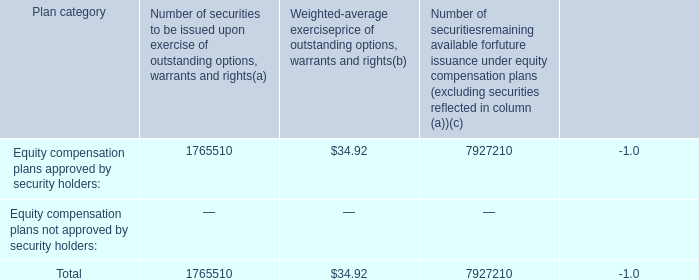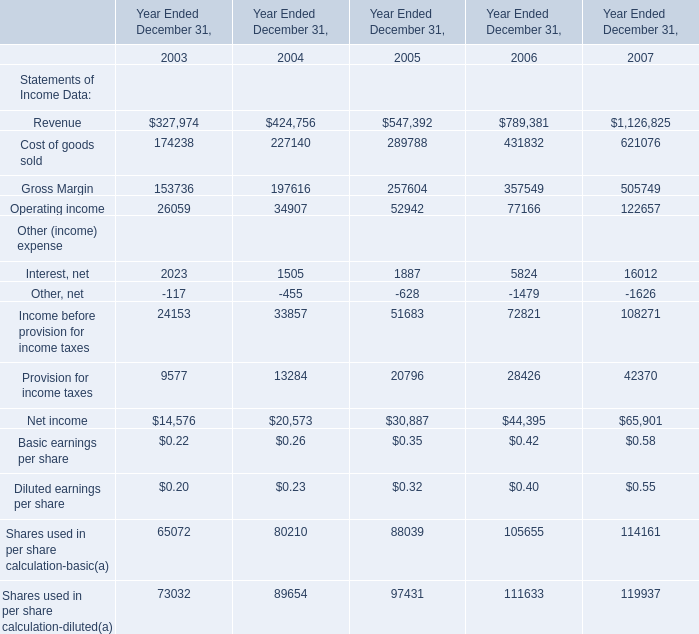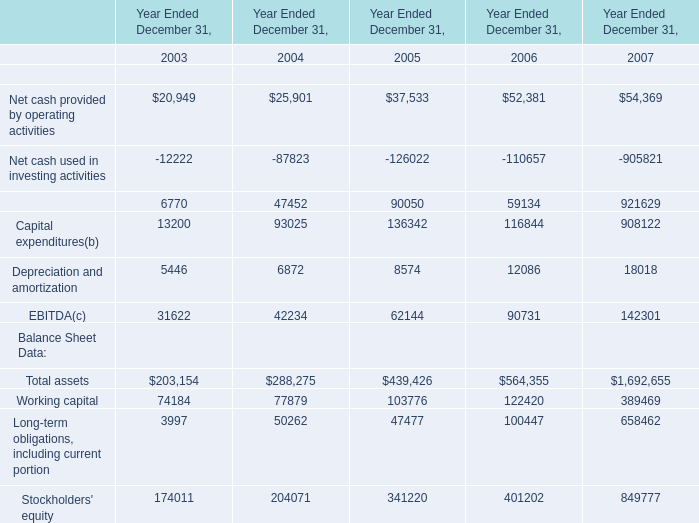Does Revenue keeps increasing each year between 2003 and 2007? 
Answer: yes. 